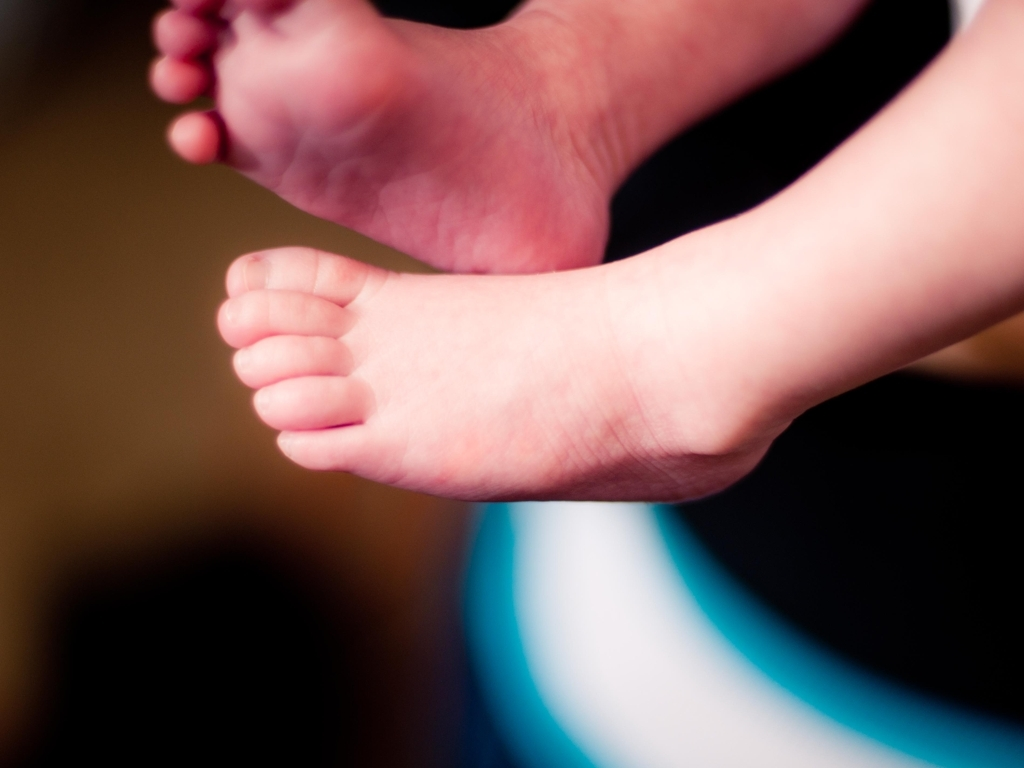What emotions or ideas could this image evoke? This image might evoke a sense of innocence, purity, and the simplicity of childhood. There's a universal warmth and tenderness associated with such images of infants or young children, which can often elicit feelings of affection and nostalgia from the viewer. 